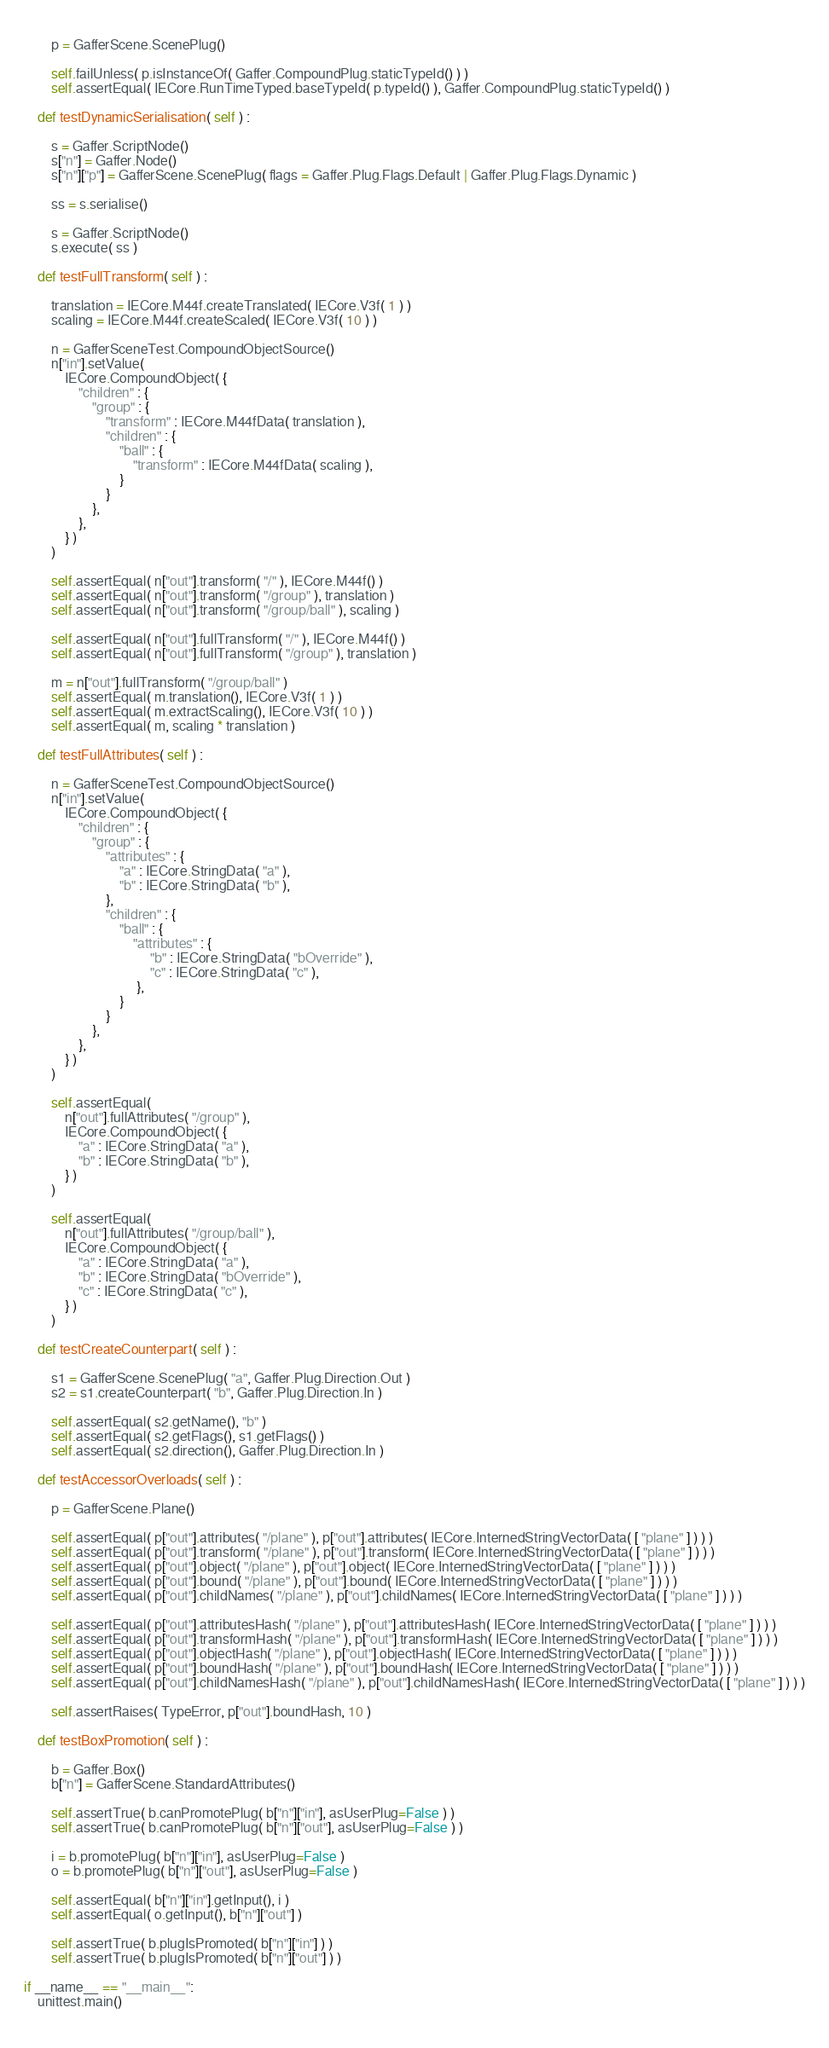<code> <loc_0><loc_0><loc_500><loc_500><_Python_>	
		p = GafferScene.ScenePlug()
		
		self.failUnless( p.isInstanceOf( Gaffer.CompoundPlug.staticTypeId() ) )	
		self.assertEqual( IECore.RunTimeTyped.baseTypeId( p.typeId() ), Gaffer.CompoundPlug.staticTypeId() )
	
	def testDynamicSerialisation( self ) :
	
		s = Gaffer.ScriptNode()
		s["n"] = Gaffer.Node()
		s["n"]["p"] = GafferScene.ScenePlug( flags = Gaffer.Plug.Flags.Default | Gaffer.Plug.Flags.Dynamic )
		
		ss = s.serialise()
				
		s = Gaffer.ScriptNode()
		s.execute( ss )
	
	def testFullTransform( self ) :
	
		translation = IECore.M44f.createTranslated( IECore.V3f( 1 ) )
		scaling = IECore.M44f.createScaled( IECore.V3f( 10 ) )
	
		n = GafferSceneTest.CompoundObjectSource()
		n["in"].setValue(
			IECore.CompoundObject( {
				"children" : {
					"group" : {
						"transform" : IECore.M44fData( translation ),
						"children" : {
							"ball" : {
								"transform" : IECore.M44fData( scaling ),			
							}
						}
					},
				},
			} )
		)
		
		self.assertEqual( n["out"].transform( "/" ), IECore.M44f() ) 
		self.assertEqual( n["out"].transform( "/group" ), translation )
		self.assertEqual( n["out"].transform( "/group/ball" ), scaling )
		
		self.assertEqual( n["out"].fullTransform( "/" ), IECore.M44f() )
		self.assertEqual( n["out"].fullTransform( "/group" ), translation )
		
		m = n["out"].fullTransform( "/group/ball" )
		self.assertEqual( m.translation(), IECore.V3f( 1 ) )
		self.assertEqual( m.extractScaling(), IECore.V3f( 10 ) )
		self.assertEqual( m, scaling * translation )
		
	def testFullAttributes( self ) :
		
		n = GafferSceneTest.CompoundObjectSource()
		n["in"].setValue(
			IECore.CompoundObject( {
				"children" : {
					"group" : {
						"attributes" : {
							"a" : IECore.StringData( "a" ),
							"b" : IECore.StringData( "b" ),
						},
						"children" : {
							"ball" : {
								"attributes" : {
									 "b" : IECore.StringData( "bOverride" ),
									 "c" : IECore.StringData( "c" ),
								 },
							}
						}
					},
				},
			} )
		)
		
		self.assertEqual(
			n["out"].fullAttributes( "/group" ),
			IECore.CompoundObject( {
				"a" : IECore.StringData( "a" ),
				"b" : IECore.StringData( "b" ),
			} )
		)
	
		self.assertEqual(
			n["out"].fullAttributes( "/group/ball" ),
			IECore.CompoundObject( {
				"a" : IECore.StringData( "a" ),
				"b" : IECore.StringData( "bOverride" ),
				"c" : IECore.StringData( "c" ),
			} )
		)
		
	def testCreateCounterpart( self ) :
	
		s1 = GafferScene.ScenePlug( "a", Gaffer.Plug.Direction.Out )
		s2 = s1.createCounterpart( "b", Gaffer.Plug.Direction.In )
		
		self.assertEqual( s2.getName(), "b" )
		self.assertEqual( s2.getFlags(), s1.getFlags() )
		self.assertEqual( s2.direction(), Gaffer.Plug.Direction.In )
	
	def testAccessorOverloads( self ) :
	
		p = GafferScene.Plane()
		
		self.assertEqual( p["out"].attributes( "/plane" ), p["out"].attributes( IECore.InternedStringVectorData( [ "plane" ] ) ) )
		self.assertEqual( p["out"].transform( "/plane" ), p["out"].transform( IECore.InternedStringVectorData( [ "plane" ] ) ) )
		self.assertEqual( p["out"].object( "/plane" ), p["out"].object( IECore.InternedStringVectorData( [ "plane" ] ) ) )
		self.assertEqual( p["out"].bound( "/plane" ), p["out"].bound( IECore.InternedStringVectorData( [ "plane" ] ) ) )
		self.assertEqual( p["out"].childNames( "/plane" ), p["out"].childNames( IECore.InternedStringVectorData( [ "plane" ] ) ) )
	
		self.assertEqual( p["out"].attributesHash( "/plane" ), p["out"].attributesHash( IECore.InternedStringVectorData( [ "plane" ] ) ) )
		self.assertEqual( p["out"].transformHash( "/plane" ), p["out"].transformHash( IECore.InternedStringVectorData( [ "plane" ] ) ) )
		self.assertEqual( p["out"].objectHash( "/plane" ), p["out"].objectHash( IECore.InternedStringVectorData( [ "plane" ] ) ) )
		self.assertEqual( p["out"].boundHash( "/plane" ), p["out"].boundHash( IECore.InternedStringVectorData( [ "plane" ] ) ) )
		self.assertEqual( p["out"].childNamesHash( "/plane" ), p["out"].childNamesHash( IECore.InternedStringVectorData( [ "plane" ] ) ) )
		
		self.assertRaises( TypeError, p["out"].boundHash, 10 )
	
	def testBoxPromotion( self ) :
	
		b = Gaffer.Box()
		b["n"] = GafferScene.StandardAttributes()
		
		self.assertTrue( b.canPromotePlug( b["n"]["in"], asUserPlug=False ) )
		self.assertTrue( b.canPromotePlug( b["n"]["out"], asUserPlug=False ) )
		
		i = b.promotePlug( b["n"]["in"], asUserPlug=False )
		o = b.promotePlug( b["n"]["out"], asUserPlug=False )
		
		self.assertEqual( b["n"]["in"].getInput(), i )
		self.assertEqual( o.getInput(), b["n"]["out"] )
		
		self.assertTrue( b.plugIsPromoted( b["n"]["in"] ) )
		self.assertTrue( b.plugIsPromoted( b["n"]["out"] ) )
		
if __name__ == "__main__":
	unittest.main()
	
</code> 